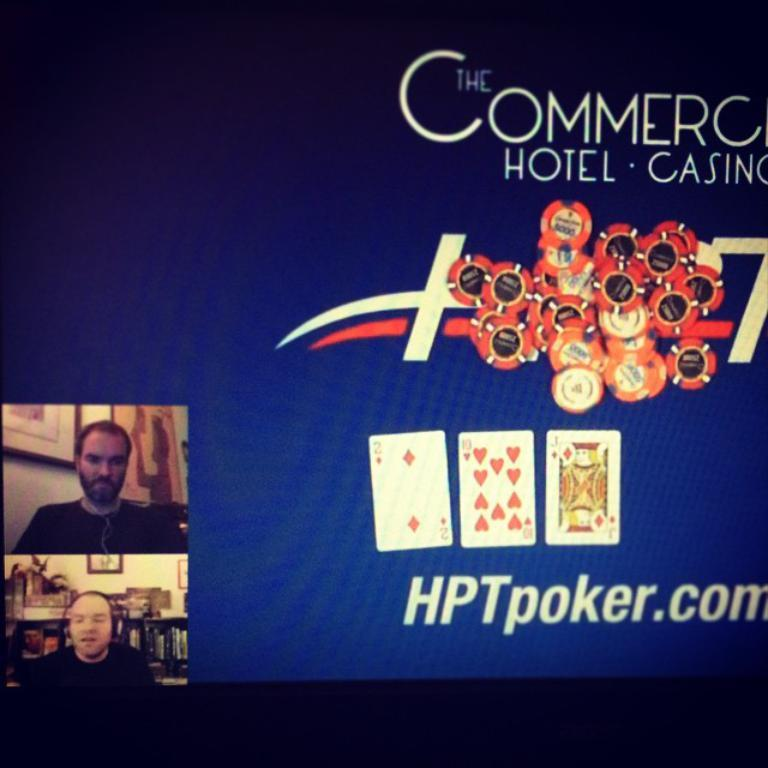What is displayed on the screen in the image? There is a display screen with text in the image. What type of objects can be seen near the screen? Coins and cards are visible in the image. Are there any people in the image? Yes, there are people in the image. What type of joke can be seen in the image? There is no joke present in the image; it features a display screen with text, coins, cards, and people. Can you tell me how many jellyfish are swimming in the image? There are no jellyfish present in the image. 